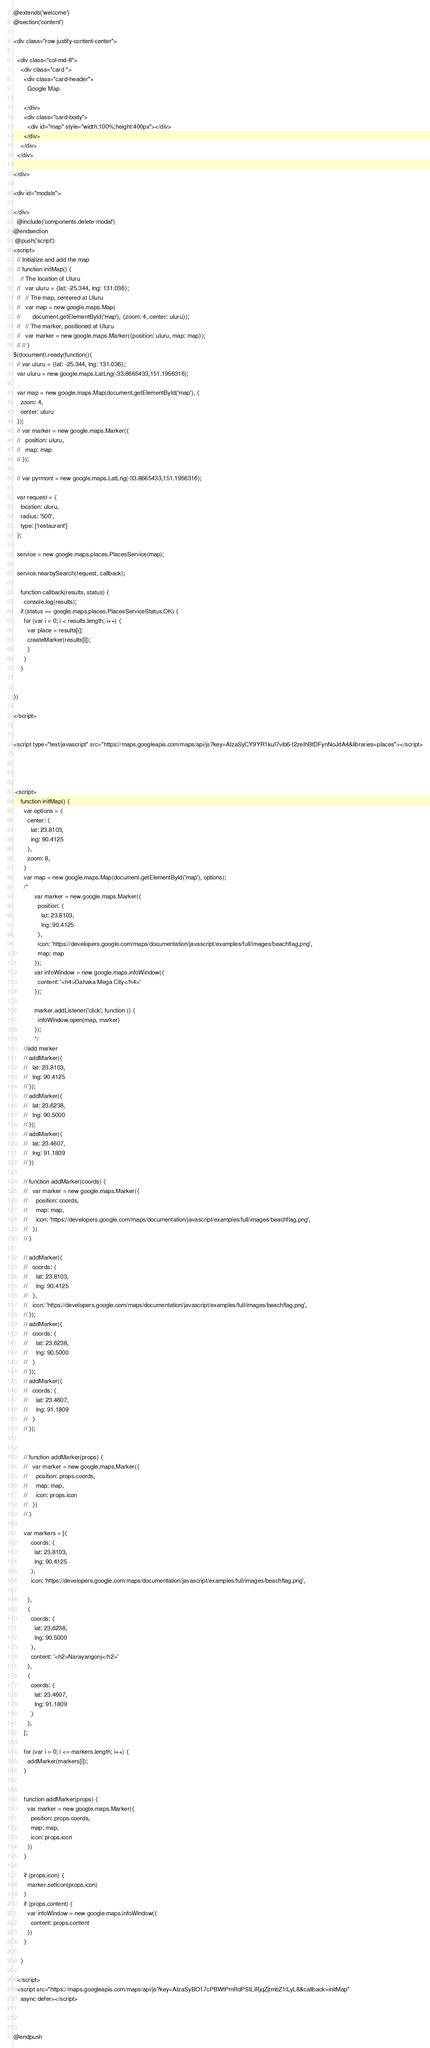Convert code to text. <code><loc_0><loc_0><loc_500><loc_500><_PHP_>@extends('welcome') 
@section('content')

<div class="row justify-content-center">

  <div class="col-md-8">
    <div class="card ">
      <div class="card-header">
        Google Map

      </div>
      <div class="card-body">
        <div id="map" style="width:100%;height:400px"></div>
      </div>
    </div>
  </div>

</div>

<div id="modals">

</div>
  @include('components.delete-modal')
@endsection
 @push('script')
<script>
  // Initialize and add the map
  // function initMap() {
    // The location of Uluru
  //   var uluru = {lat: -25.344, lng: 131.036};
  //   // The map, centered at Uluru
  //   var map = new google.maps.Map(
  //       document.getElementById('map'), {zoom: 4, center: uluru});
  //   // The marker, positioned at Uluru
  //   var marker = new google.maps.Marker({position: uluru, map: map});
  // // }
$(document).ready(function(){
  // var uluru = {lat: -25.344, lng: 131.036};
  var uluru = new google.maps.LatLng(-33.8665433,151.1956316);

  var map = new google.maps.Map(document.getElementById('map'), {
    zoom: 4,
    center: uluru
  });
  // var marker = new google.maps.Marker({
  //   position: uluru,
  //   map: map
  // });

  // var pyrmont = new google.maps.LatLng(-33.8665433,151.1956316);

  var request = {
    location: uluru,
    radius: '500',
    type: ['restaurant']
  };
 
  service = new google.maps.places.PlacesService(map);
  
  service.nearbySearch(request, callback);

    function callback(results, status) {
      console.log(results);
    if (status == google.maps.places.PlacesServiceStatus.OK) {
      for (var i = 0; i < results.length; i++) {
        var place = results[i];
        createMarker(results[i]);
        }
      }
    }


})

</script>


<script type="text/javascript" src="https://maps.googleapis.com/maps/api/js?key=AIzaSyCY9YR1kuI7vib6-t2zeIhBtDFynNoJdA4&libraries=places"></script>




 <script>
    function initMap() {
      var options = {
        center: {
          lat: 23.8103,
          lng: 90.4125
        },
        zoom: 8,
      }
      var map = new google.maps.Map(document.getElementById('map'), options);
      /*
            var marker = new google.maps.Marker({
              position: {
                lat: 23.8103,
                lng: 90.4125
              },
              icon: 'https://developers.google.com/maps/documentation/javascript/examples/full/images/beachflag.png',
              map: map
            });
            var infoWindow = new google.maps.infoWindow({
              content: '<h4>Dahaka Mega City</h4>'
            });

            marker.addListener('click', function () {
              infoWindow.open(map, marker)
            });
            */
      //add marker
      // addMarker({
      //   lat: 23.8103,
      //   lng: 90.4125
      // });
      // addMarker({
      //   lat: 23.6238,
      //   lng: 90.5000
      // });
      // addMarker({
      //   lat: 23.4607,
      //   lng: 91.1809
      // })

      // function addMarker(coords) {
      //   var marker = new google.maps.Marker({
      //     position: coords,
      //     map: map,
      //     icon: 'https://developers.google.com/maps/documentation/javascript/examples/full/images/beachflag.png',
      //   })
      // }

      // addMarker({
      //   coords: {
      //     lat: 23.8103,
      //     lng: 90.4125
      //   },
      //   icon: 'https://developers.google.com/maps/documentation/javascript/examples/full/images/beachflag.png',
      // });
      // addMarker({
      //   coords: {
      //     lat: 23.6238,
      //     lng: 90.5000
      //   }
      // });
      // addMarker({
      //   coords: {
      //     lat: 23.4607,
      //     lng: 91.1809
      //   }
      // });


      // function addMarker(props) {
      //   var marker = new google.maps.Marker({
      //     position: props.coords,
      //     map: map,
      //     icon: props.icon
      //   })
      // }

      var markers = [{
          coords: {
            lat: 23.8103,
            lng: 90.4125
          },
          icon: 'https://developers.google.com/maps/documentation/javascript/examples/full/images/beachflag.png',

        },
        {
          coords: {
            lat: 23.6238,
            lng: 90.5000
          },
          content: '<h2>Narayangonj</h2>'
        },
        {
          coords: {
            lat: 23.4607,
            lng: 91.1809
          }
        },
      ];

      for (var i = 0; i <= markers.length; i++) {
        addMarker(markers[i]);
      }


      function addMarker(props) {
        var marker = new google.maps.Marker({
          position: props.coords,
          map: map,
          icon: props.icon
        })
      }

      if (props.icon) {
        marker.setIcon(props.icon)
      }
      if (props.content) {
        var infoWindow = new google.maps.infoWindow({
          content: props.content
        })
      }

    }

  </script>
  <script src="https://maps.googleapis.com/maps/api/js?key=AIzaSyBO17cPBWtPmRdPSILiRjqZjtmbZ1lLyL8&callback=initMap"
    async defer></script>



@endpush</code> 